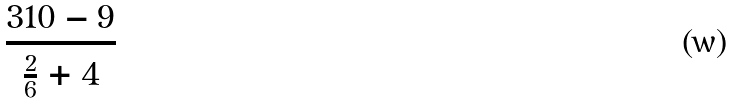Convert formula to latex. <formula><loc_0><loc_0><loc_500><loc_500>\frac { 3 1 0 - 9 } { \frac { 2 } { 6 } + 4 }</formula> 